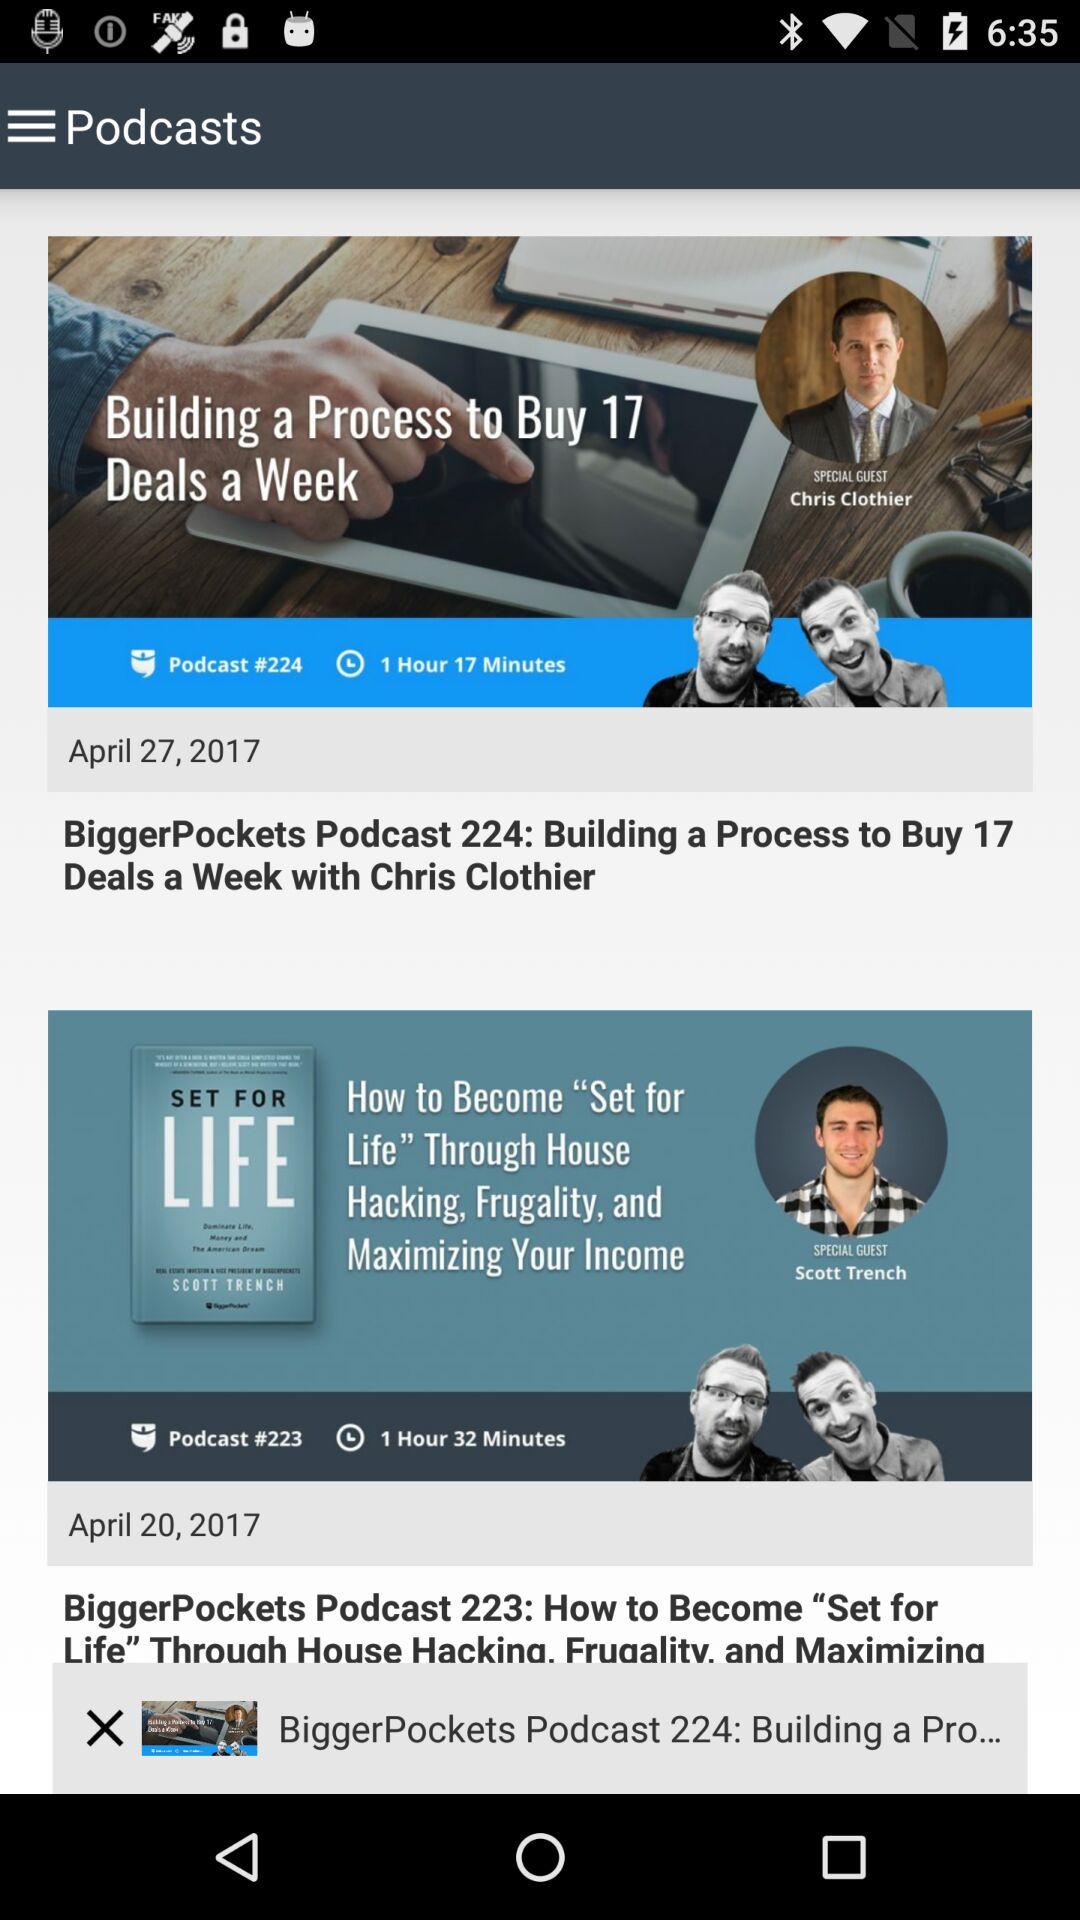When was "BiggerPockets Podcast 223" published? "BiggerPockets Podcast 223" was published on April 20, 2017. 